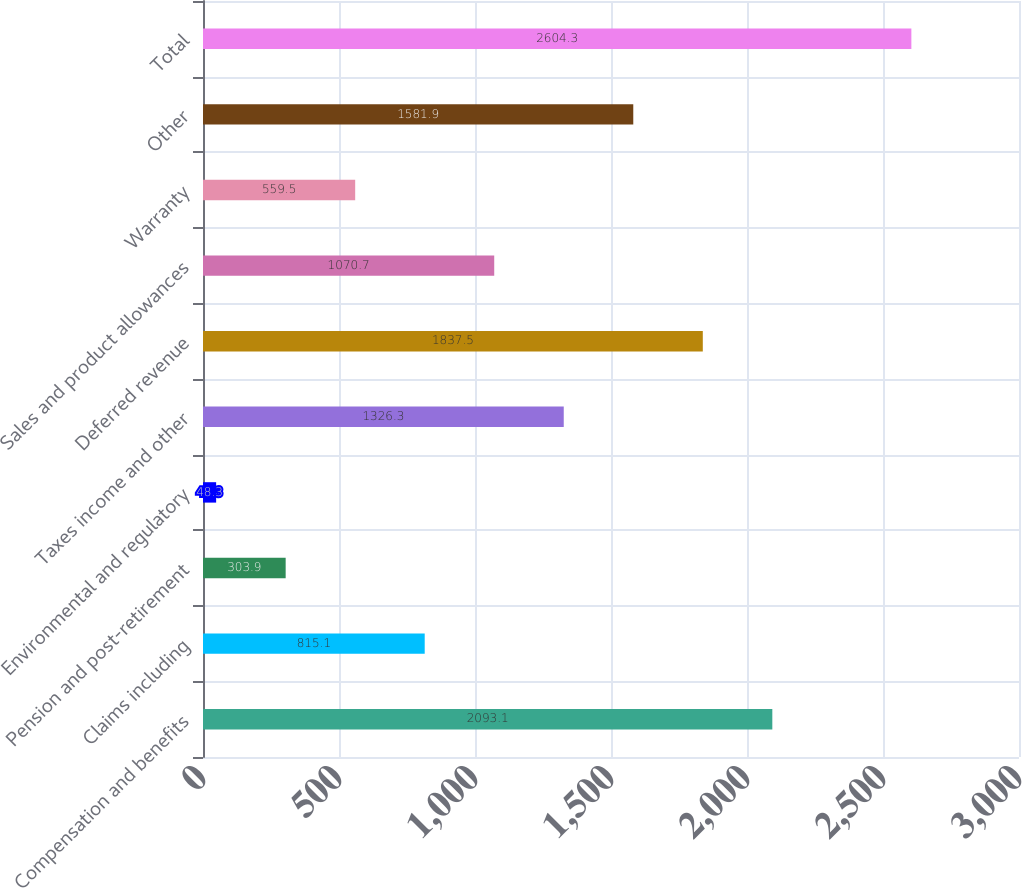Convert chart. <chart><loc_0><loc_0><loc_500><loc_500><bar_chart><fcel>Compensation and benefits<fcel>Claims including<fcel>Pension and post-retirement<fcel>Environmental and regulatory<fcel>Taxes income and other<fcel>Deferred revenue<fcel>Sales and product allowances<fcel>Warranty<fcel>Other<fcel>Total<nl><fcel>2093.1<fcel>815.1<fcel>303.9<fcel>48.3<fcel>1326.3<fcel>1837.5<fcel>1070.7<fcel>559.5<fcel>1581.9<fcel>2604.3<nl></chart> 